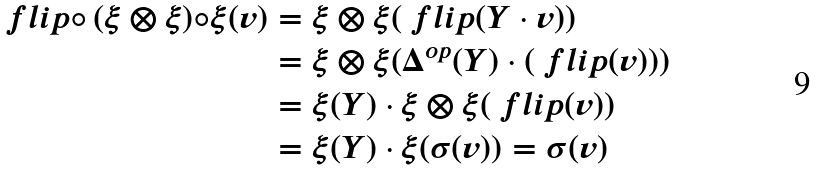Convert formula to latex. <formula><loc_0><loc_0><loc_500><loc_500>\ f l i p \circ \, ( \xi \otimes \xi ) \circ \xi ( v ) & = \xi \otimes \xi ( \ f l i p ( Y \cdot v ) ) \\ & = \xi \otimes \xi ( \Delta ^ { o p } ( Y ) \cdot ( \ f l i p ( v ) ) ) \\ & = \xi ( Y ) \cdot \xi \otimes \xi ( \ f l i p ( v ) ) \\ & = \xi ( Y ) \cdot \xi ( \sigma ( v ) ) = \sigma ( v )</formula> 